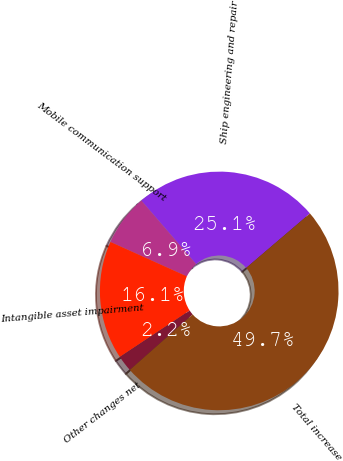Convert chart to OTSL. <chart><loc_0><loc_0><loc_500><loc_500><pie_chart><fcel>Ship engineering and repair<fcel>Mobile communication support<fcel>Intangible asset impairment<fcel>Other changes net<fcel>Total increase<nl><fcel>25.07%<fcel>6.94%<fcel>16.07%<fcel>2.19%<fcel>49.73%<nl></chart> 